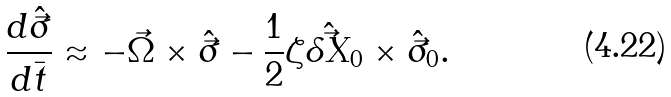Convert formula to latex. <formula><loc_0><loc_0><loc_500><loc_500>\frac { d \hat { \vec { \sigma } } } { d \bar { t } } \approx - \vec { \Omega } \times \hat { \vec { \sigma } } - \frac { 1 } { 2 } \zeta \hat { \vec { \delta X } } _ { 0 } \times \hat { \vec { \sigma } } _ { 0 } .</formula> 